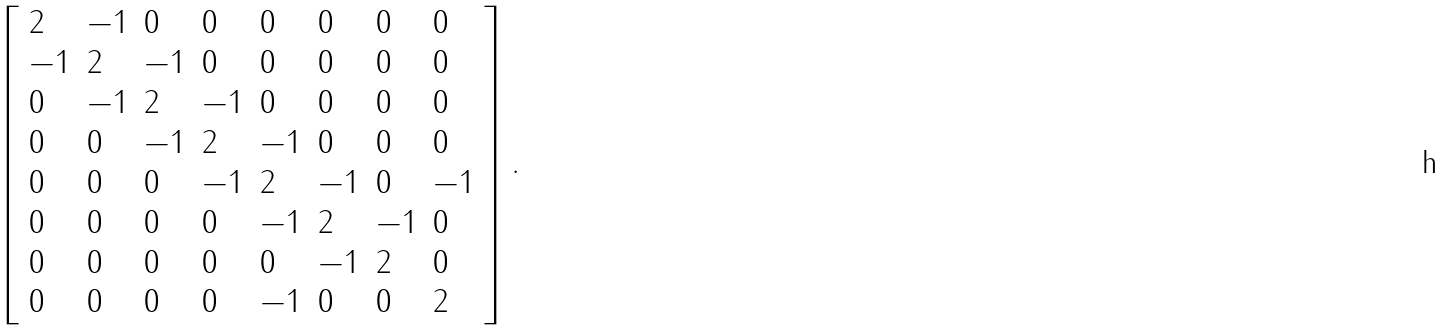Convert formula to latex. <formula><loc_0><loc_0><loc_500><loc_500>\left [ { \begin{array} { l l l l l l l l } { 2 } & { - 1 } & { 0 } & { 0 } & { 0 } & { 0 } & { 0 } & { 0 } \\ { - 1 } & { 2 } & { - 1 } & { 0 } & { 0 } & { 0 } & { 0 } & { 0 } \\ { 0 } & { - 1 } & { 2 } & { - 1 } & { 0 } & { 0 } & { 0 } & { 0 } \\ { 0 } & { 0 } & { - 1 } & { 2 } & { - 1 } & { 0 } & { 0 } & { 0 } \\ { 0 } & { 0 } & { 0 } & { - 1 } & { 2 } & { - 1 } & { 0 } & { - 1 } \\ { 0 } & { 0 } & { 0 } & { 0 } & { - 1 } & { 2 } & { - 1 } & { 0 } \\ { 0 } & { 0 } & { 0 } & { 0 } & { 0 } & { - 1 } & { 2 } & { 0 } \\ { 0 } & { 0 } & { 0 } & { 0 } & { - 1 } & { 0 } & { 0 } & { 2 } \end{array} } \right ] .</formula> 